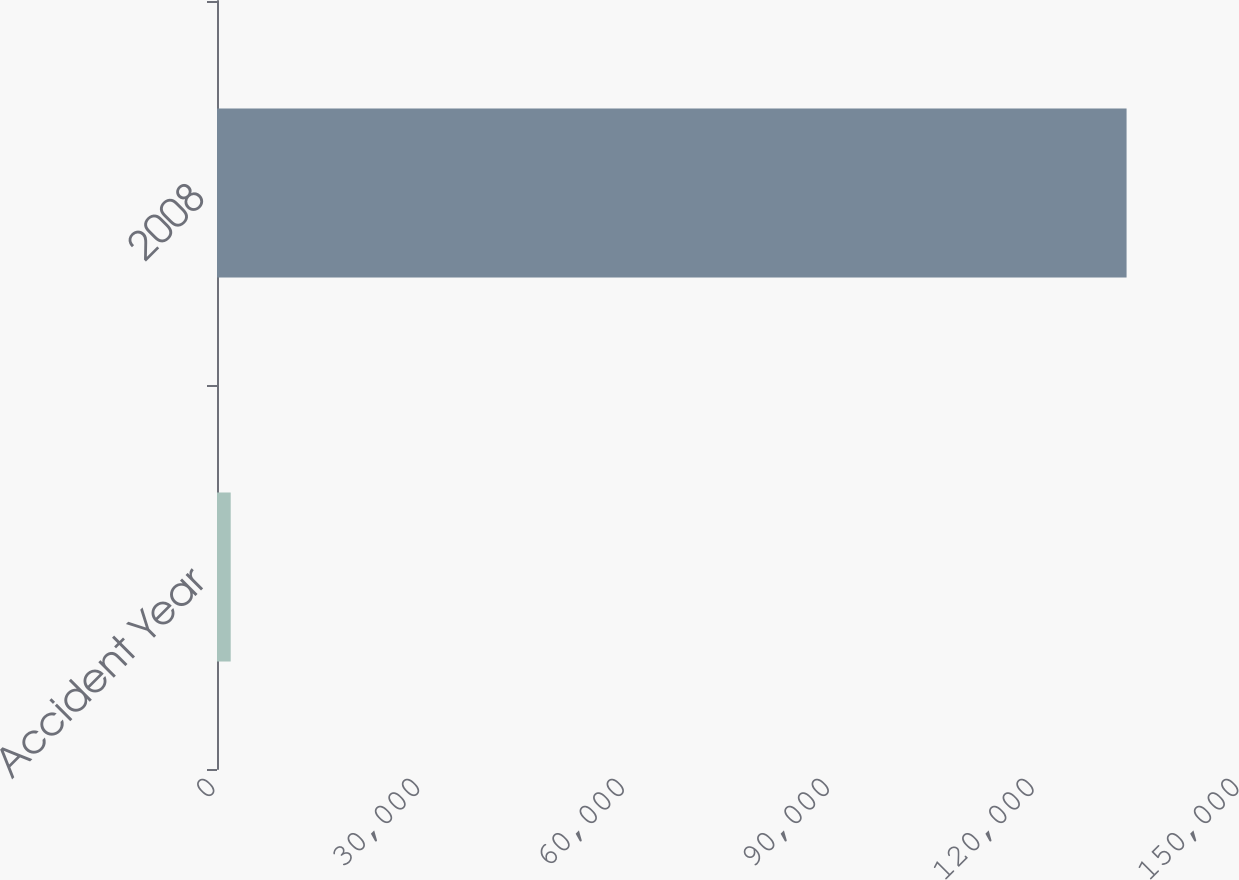Convert chart to OTSL. <chart><loc_0><loc_0><loc_500><loc_500><bar_chart><fcel>Accident Year<fcel>2008<nl><fcel>2009<fcel>133238<nl></chart> 